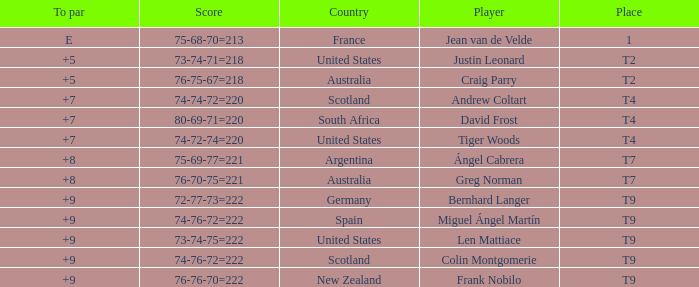What is the To Par score for the player from South Africa? 7.0. 